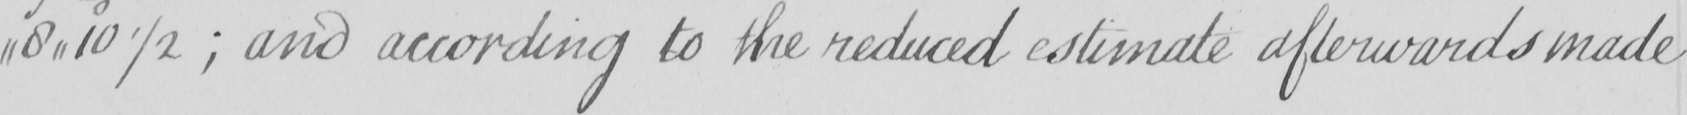What text is written in this handwritten line? 8,,10 1/2  ; and according to the reduced estimate afterwards made 